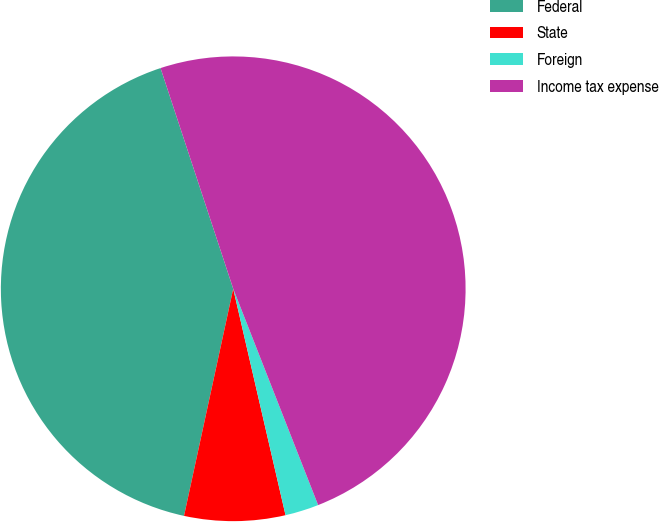Convert chart. <chart><loc_0><loc_0><loc_500><loc_500><pie_chart><fcel>Federal<fcel>State<fcel>Foreign<fcel>Income tax expense<nl><fcel>41.54%<fcel>7.01%<fcel>2.34%<fcel>49.11%<nl></chart> 